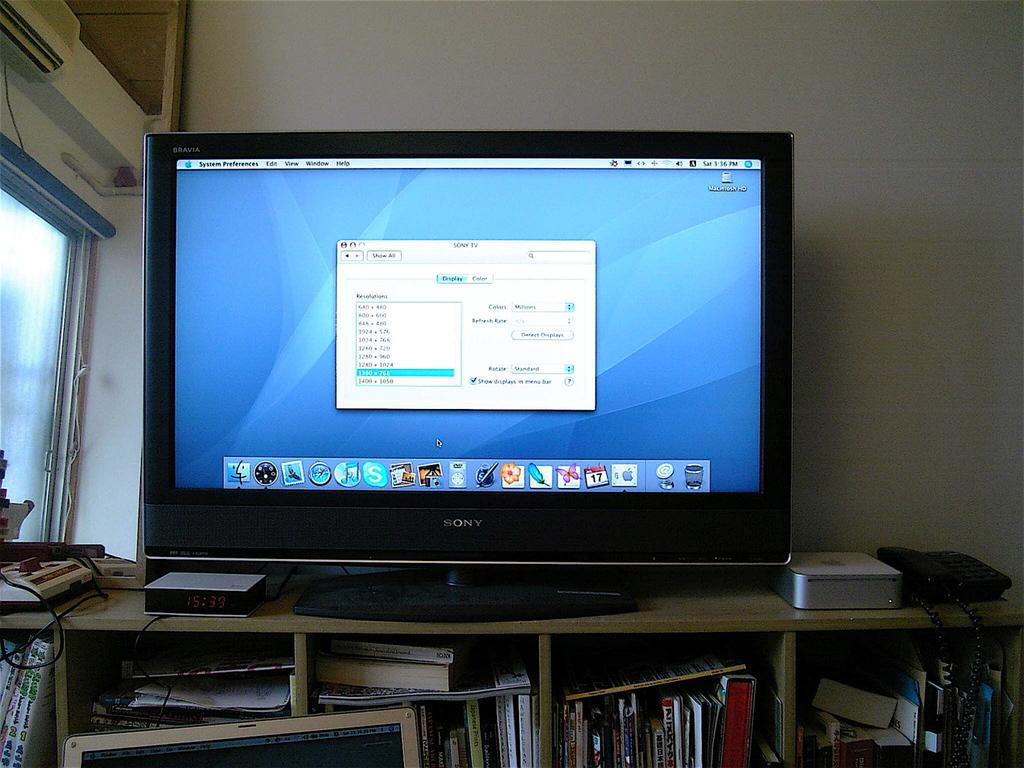<image>
Describe the image concisely. The sony monitor is sitting on top of the bookshelf at 3:36pm. 